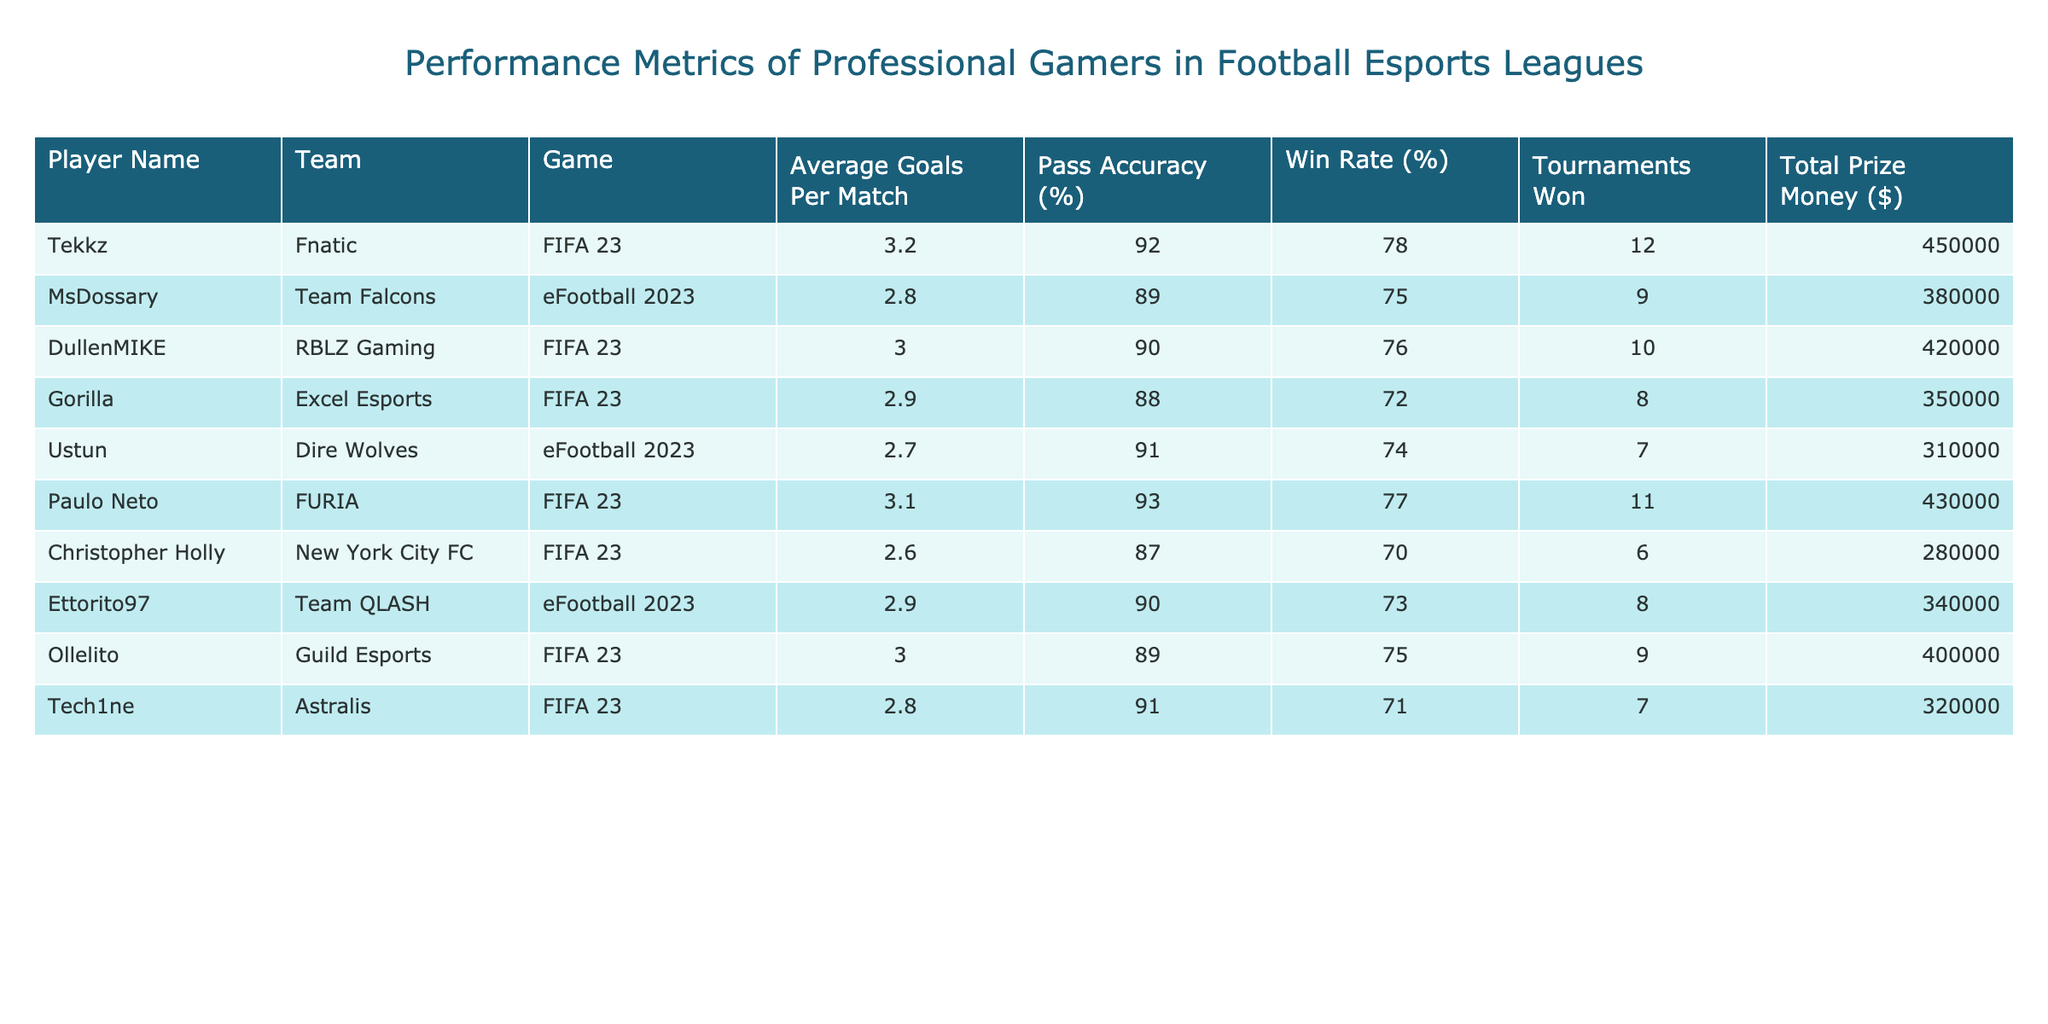What player has the highest average goals per match? The player with the highest average goals per match is Tekkz with an average of 3.2 goals.
Answer: Tekkz Which player has the lowest pass accuracy percentage? Christopher Holly has the lowest pass accuracy percentage at 87%.
Answer: Christopher Holly What is the total prize money won by MsDossary and Ettorito97 combined? MsDossary won $380,000 and Ettorito97 won $340,000. Adding these amounts gives $380,000 + $340,000 = $720,000.
Answer: $720,000 Which player has a win rate of 74%? Ustun has a win rate of 74%.
Answer: Ustun How many tournaments did Paulo Neto win compared to DullenMIKE? Paulo Neto won 11 tournaments while DullenMIKE won 10 tournaments. The difference is 11 - 10 = 1 tournament. So, Paulo Neto won 1 more tournament than DullenMIKE.
Answer: 1 Is Ollelito's pass accuracy higher than 90%? Ollelito’s pass accuracy is 89%, which is not higher than 90%.
Answer: No What is the average win rate of the players in the table? To find the average win rate, sum all the win rates: 78 + 75 + 76 + 72 + 74 + 77 + 70 + 73 + 75 + 71 = 746. Then divide by the number of players, which is 10: 746 / 10 = 74.6%.
Answer: 74.6% Which team has the most tournaments won by its player? Tekkz from Fnatic has won 12 tournaments, which is the highest among all players.
Answer: Fnatic What is the total prize money earned by players from FIFA 23? Players from FIFA 23 are Tekkz ($450,000), DullenMIKE ($420,000), Paulo Neto ($430,000), Christopher Holly ($280,000), Ollelito ($400,000), and Tech1ne ($320,000). Adding these gives: $450,000 + $420,000 + $430,000 + $280,000 + $400,000 + $320,000 = $2,300,000.
Answer: $2,300,000 Does any player from eFootball 2023 have more than two tournaments won? The players from eFootball 2023 are MsDossary, Ustun, and Ettorito97, who have won 9, 7, and 8 tournaments respectively. MsDossary has the most tournaments won, which is more than 2.
Answer: Yes 